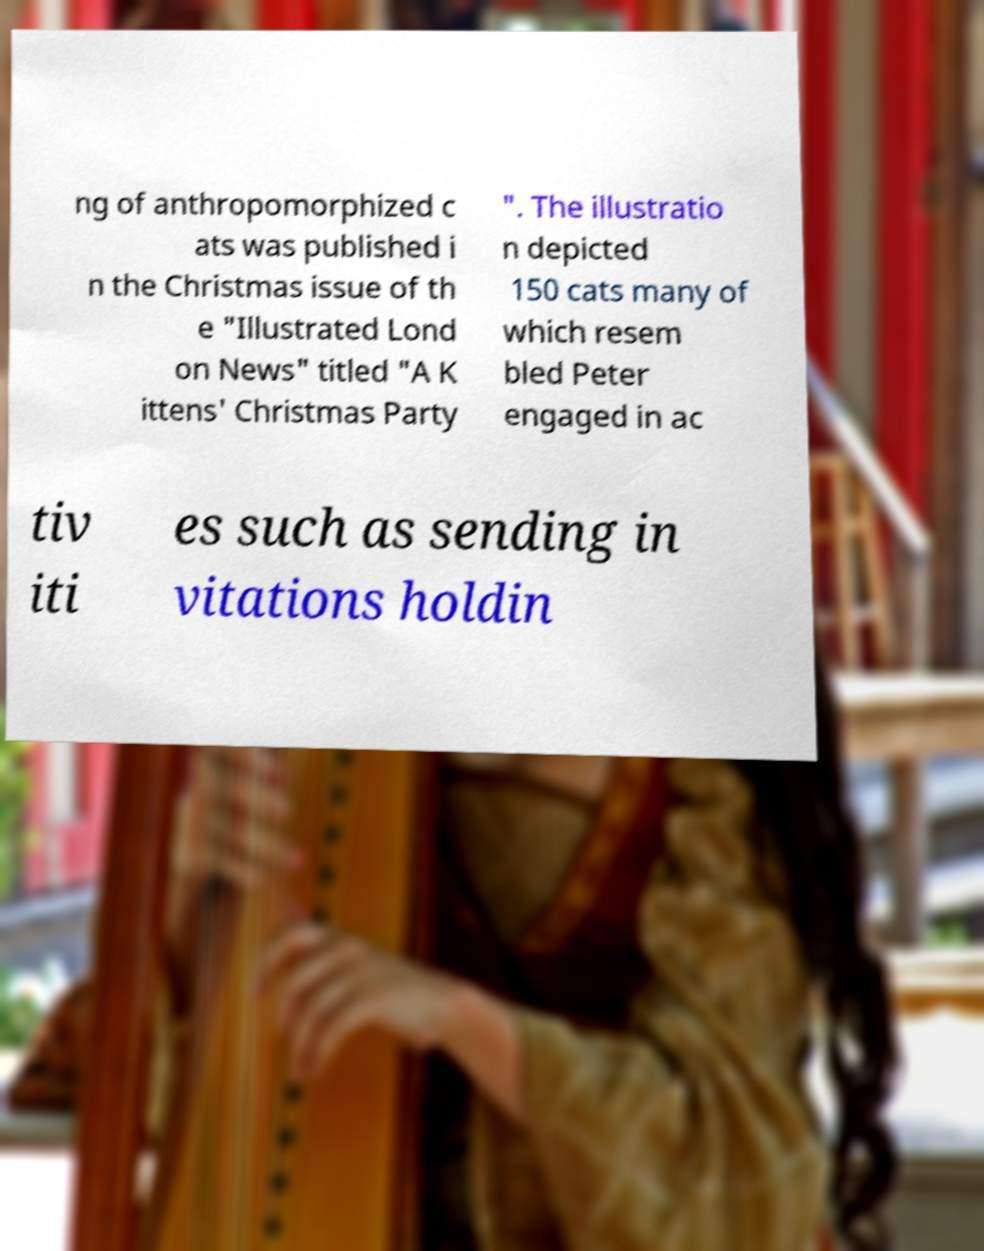Can you accurately transcribe the text from the provided image for me? ng of anthropomorphized c ats was published i n the Christmas issue of th e "Illustrated Lond on News" titled "A K ittens' Christmas Party ". The illustratio n depicted 150 cats many of which resem bled Peter engaged in ac tiv iti es such as sending in vitations holdin 